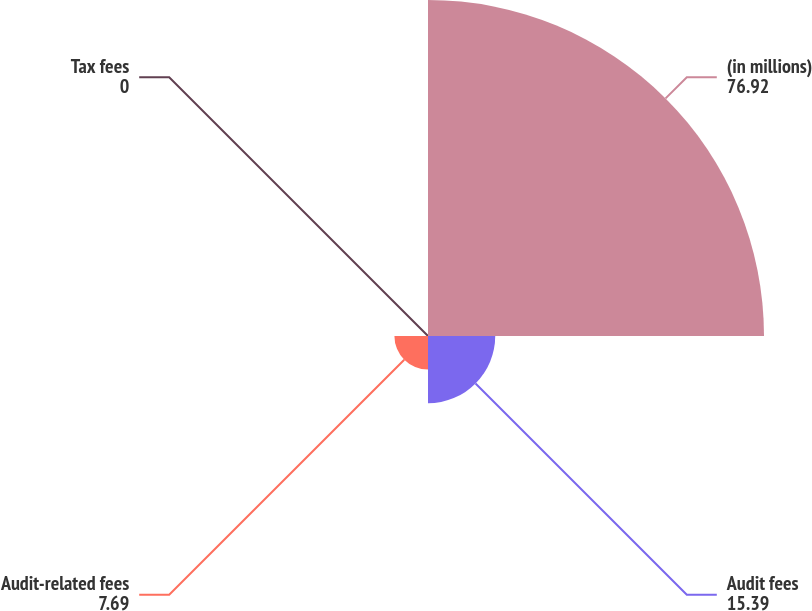Convert chart. <chart><loc_0><loc_0><loc_500><loc_500><pie_chart><fcel>(in millions)<fcel>Audit fees<fcel>Audit-related fees<fcel>Tax fees<nl><fcel>76.92%<fcel>15.39%<fcel>7.69%<fcel>0.0%<nl></chart> 